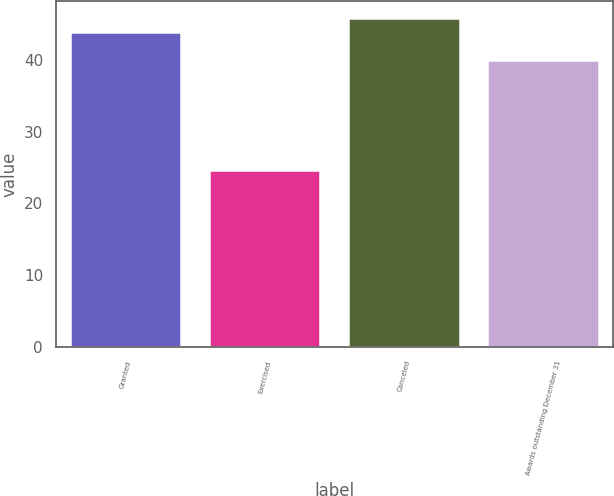Convert chart to OTSL. <chart><loc_0><loc_0><loc_500><loc_500><bar_chart><fcel>Granted<fcel>Exercised<fcel>Canceled<fcel>Awards outstanding December 31<nl><fcel>43.84<fcel>24.67<fcel>45.89<fcel>39.91<nl></chart> 